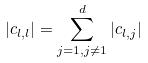Convert formula to latex. <formula><loc_0><loc_0><loc_500><loc_500>| c _ { l , l } | = \sum _ { j = 1 , j \ne 1 } ^ { d } | c _ { l , j } |</formula> 